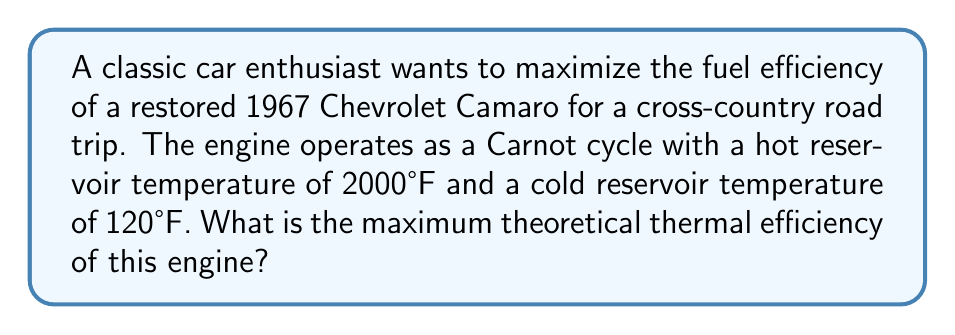Teach me how to tackle this problem. To solve this problem, we'll use the principles of thermodynamics and the Carnot cycle efficiency formula:

1. First, we need to convert the temperatures from Fahrenheit to Kelvin:
   Hot reservoir: $T_H = (2000°F - 32) \times \frac{5}{9} + 273.15 = 1366.48 K$
   Cold reservoir: $T_C = (120°F - 32) \times \frac{5}{9} + 273.15 = 322.04 K$

2. The Carnot efficiency formula is:
   $$\eta = 1 - \frac{T_C}{T_H}$$

   Where:
   $\eta$ is the thermal efficiency
   $T_C$ is the temperature of the cold reservoir in Kelvin
   $T_H$ is the temperature of the hot reservoir in Kelvin

3. Substituting the values:
   $$\eta = 1 - \frac{322.04 K}{1366.48 K}$$

4. Calculating:
   $$\eta = 1 - 0.2356 = 0.7644$$

5. Converting to percentage:
   $$\eta = 0.7644 \times 100\% = 76.44\%$$

Therefore, the maximum theoretical thermal efficiency of the engine is 76.44%.
Answer: 76.44% 